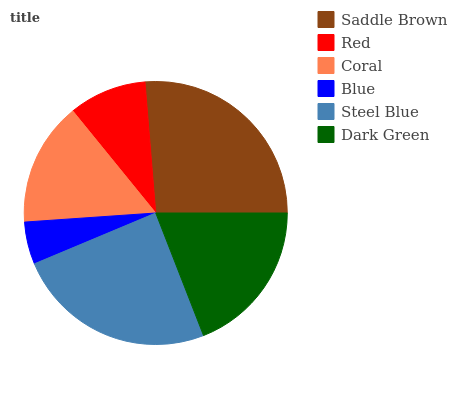Is Blue the minimum?
Answer yes or no. Yes. Is Saddle Brown the maximum?
Answer yes or no. Yes. Is Red the minimum?
Answer yes or no. No. Is Red the maximum?
Answer yes or no. No. Is Saddle Brown greater than Red?
Answer yes or no. Yes. Is Red less than Saddle Brown?
Answer yes or no. Yes. Is Red greater than Saddle Brown?
Answer yes or no. No. Is Saddle Brown less than Red?
Answer yes or no. No. Is Dark Green the high median?
Answer yes or no. Yes. Is Coral the low median?
Answer yes or no. Yes. Is Red the high median?
Answer yes or no. No. Is Steel Blue the low median?
Answer yes or no. No. 